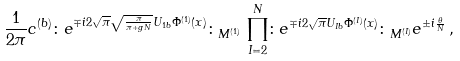Convert formula to latex. <formula><loc_0><loc_0><loc_500><loc_500>\frac { 1 } { 2 \pi } c ^ { ( b ) } \colon e ^ { \mp i 2 \sqrt { \pi } \sqrt { \frac { \pi } { \pi + g N } } U _ { 1 b } \Phi ^ { ( 1 ) } ( x ) } \colon _ { M ^ { ( 1 ) } } \, \prod _ { I = 2 } ^ { N } \colon e ^ { \mp i 2 \sqrt { \pi } U _ { I b } \Phi ^ { ( I ) } ( x ) } \colon _ { M ^ { ( I ) } } e ^ { \pm i \frac { \theta } { N } } \, ,</formula> 